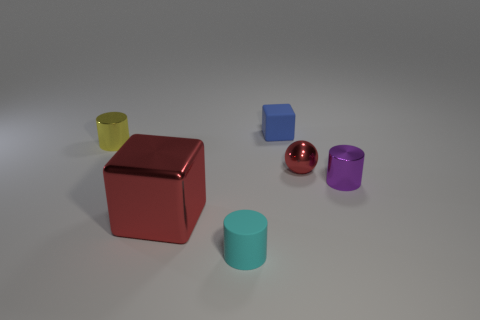Add 2 matte cubes. How many objects exist? 8 Subtract all cubes. How many objects are left? 4 Subtract all small metallic cylinders. How many cylinders are left? 1 Subtract all red cubes. How many cubes are left? 1 Subtract all gray balls. Subtract all purple cylinders. How many balls are left? 1 Subtract all yellow balls. How many purple cylinders are left? 1 Subtract all small red metallic objects. Subtract all large objects. How many objects are left? 4 Add 3 small yellow objects. How many small yellow objects are left? 4 Add 3 purple matte balls. How many purple matte balls exist? 3 Subtract 0 cyan cubes. How many objects are left? 6 